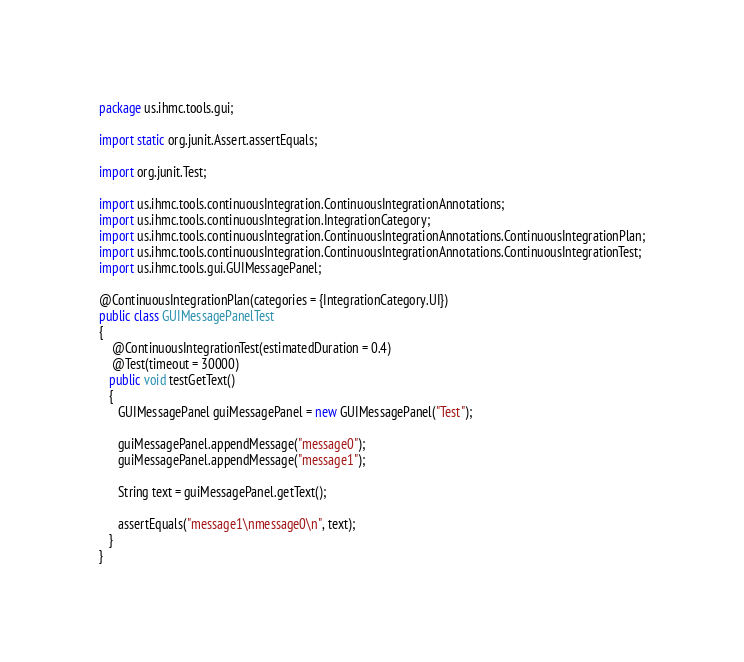Convert code to text. <code><loc_0><loc_0><loc_500><loc_500><_Java_>package us.ihmc.tools.gui;

import static org.junit.Assert.assertEquals;

import org.junit.Test;

import us.ihmc.tools.continuousIntegration.ContinuousIntegrationAnnotations;
import us.ihmc.tools.continuousIntegration.IntegrationCategory;
import us.ihmc.tools.continuousIntegration.ContinuousIntegrationAnnotations.ContinuousIntegrationPlan;
import us.ihmc.tools.continuousIntegration.ContinuousIntegrationAnnotations.ContinuousIntegrationTest;
import us.ihmc.tools.gui.GUIMessagePanel;

@ContinuousIntegrationPlan(categories = {IntegrationCategory.UI})
public class GUIMessagePanelTest
{
	@ContinuousIntegrationTest(estimatedDuration = 0.4)
	@Test(timeout = 30000)
   public void testGetText()
   {
      GUIMessagePanel guiMessagePanel = new GUIMessagePanel("Test");
      
      guiMessagePanel.appendMessage("message0");
      guiMessagePanel.appendMessage("message1");
      
      String text = guiMessagePanel.getText();
            
      assertEquals("message1\nmessage0\n", text);
   }
}
</code> 